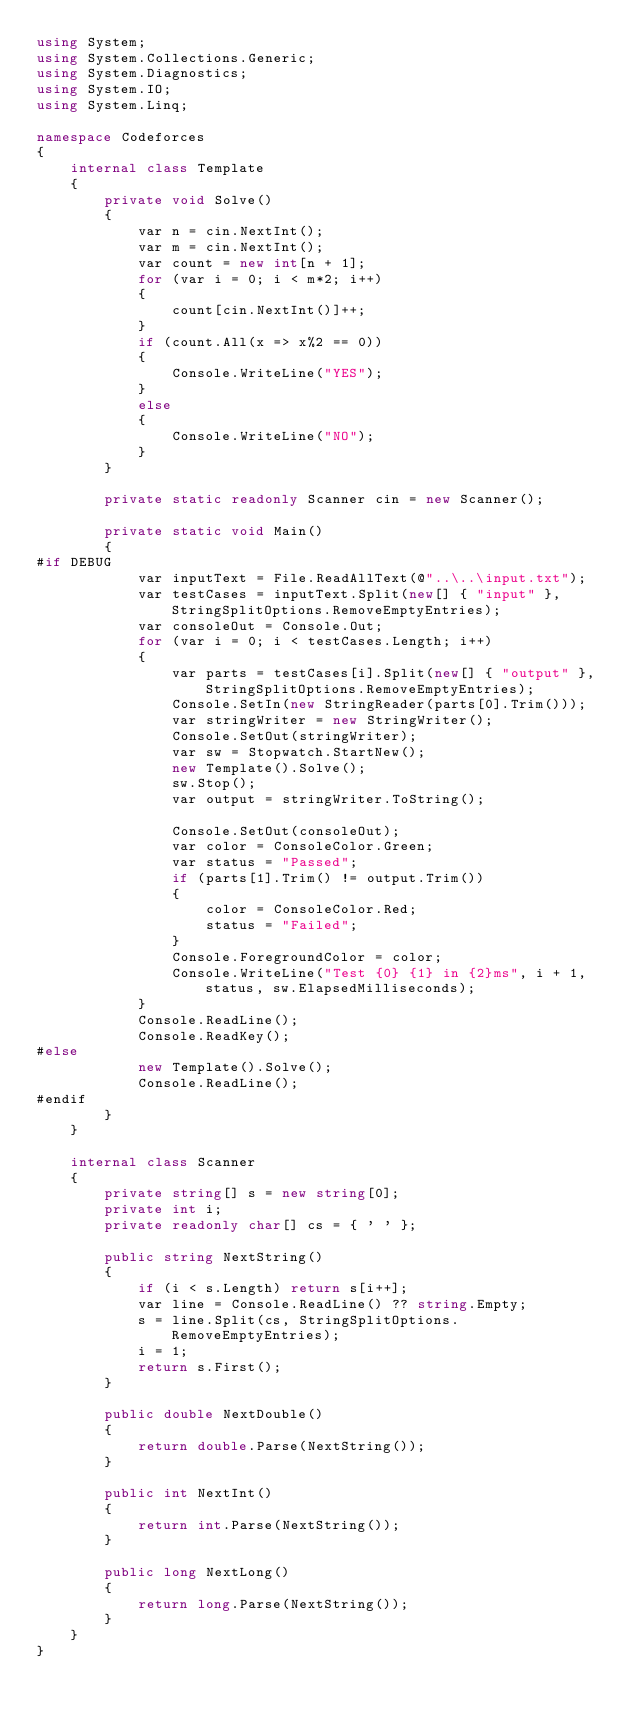Convert code to text. <code><loc_0><loc_0><loc_500><loc_500><_C#_>using System;
using System.Collections.Generic;
using System.Diagnostics;
using System.IO;
using System.Linq;

namespace Codeforces
{
	internal class Template
	{
		private void Solve()
		{
			var n = cin.NextInt();
			var m = cin.NextInt();
			var count = new int[n + 1];
			for (var i = 0; i < m*2; i++)
			{
				count[cin.NextInt()]++;
			}
			if (count.All(x => x%2 == 0))
			{
				Console.WriteLine("YES");
			}
			else
			{
				Console.WriteLine("NO");
			}
		}

		private static readonly Scanner cin = new Scanner();

		private static void Main()
		{
#if DEBUG
			var inputText = File.ReadAllText(@"..\..\input.txt");
			var testCases = inputText.Split(new[] { "input" }, StringSplitOptions.RemoveEmptyEntries);
			var consoleOut = Console.Out;
			for (var i = 0; i < testCases.Length; i++)
			{
				var parts = testCases[i].Split(new[] { "output" }, StringSplitOptions.RemoveEmptyEntries);
				Console.SetIn(new StringReader(parts[0].Trim()));
				var stringWriter = new StringWriter();
				Console.SetOut(stringWriter);
				var sw = Stopwatch.StartNew();
				new Template().Solve();
				sw.Stop();
				var output = stringWriter.ToString();

				Console.SetOut(consoleOut);
				var color = ConsoleColor.Green;
				var status = "Passed";
				if (parts[1].Trim() != output.Trim())
				{
					color = ConsoleColor.Red;
					status = "Failed";
				}
				Console.ForegroundColor = color;
				Console.WriteLine("Test {0} {1} in {2}ms", i + 1, status, sw.ElapsedMilliseconds);
			}
			Console.ReadLine();
			Console.ReadKey();
#else
			new Template().Solve();
			Console.ReadLine();
#endif
		}
	}

	internal class Scanner
	{
		private string[] s = new string[0];
		private int i;
		private readonly char[] cs = { ' ' };

		public string NextString()
		{
			if (i < s.Length) return s[i++];
			var line = Console.ReadLine() ?? string.Empty;
			s = line.Split(cs, StringSplitOptions.RemoveEmptyEntries);
			i = 1;
			return s.First();
		}

		public double NextDouble()
		{
			return double.Parse(NextString());
		}

		public int NextInt()
		{
			return int.Parse(NextString());
		}

		public long NextLong()
		{
			return long.Parse(NextString());
		}
	}
}</code> 